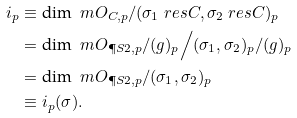<formula> <loc_0><loc_0><loc_500><loc_500>i _ { p } & \equiv \text {dim } \ m O _ { C , p } / ( \sigma _ { 1 } \ r e s { C } , \sigma _ { 2 } \ r e s { C } ) _ { p } \\ & = \text {dim } \ m O _ { \P S { 2 } , p } / ( g ) _ { p } \Big / ( \sigma _ { 1 } , \sigma _ { 2 } ) _ { p } / ( g ) _ { p } \\ & = \text {dim } \ m O _ { \P S { 2 } , p } / ( \sigma _ { 1 } , \sigma _ { 2 } ) _ { p } \\ & \equiv i _ { p } ( \sigma ) .</formula> 